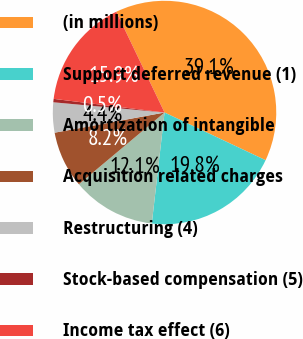Convert chart to OTSL. <chart><loc_0><loc_0><loc_500><loc_500><pie_chart><fcel>(in millions)<fcel>Support deferred revenue (1)<fcel>Amortization of intangible<fcel>Acquisition related charges<fcel>Restructuring (4)<fcel>Stock-based compensation (5)<fcel>Income tax effect (6)<nl><fcel>39.12%<fcel>19.8%<fcel>12.08%<fcel>8.21%<fcel>4.35%<fcel>0.49%<fcel>15.94%<nl></chart> 